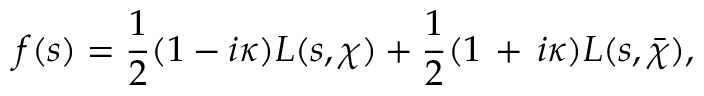<formula> <loc_0><loc_0><loc_500><loc_500>f ( s ) = { \frac { 1 } { 2 } } ( 1 - i \kappa ) L ( s , \chi ) + { \frac { 1 } { 2 } } ( 1 \, + \, i \kappa ) L ( s , { \bar { \chi } } ) ,</formula> 